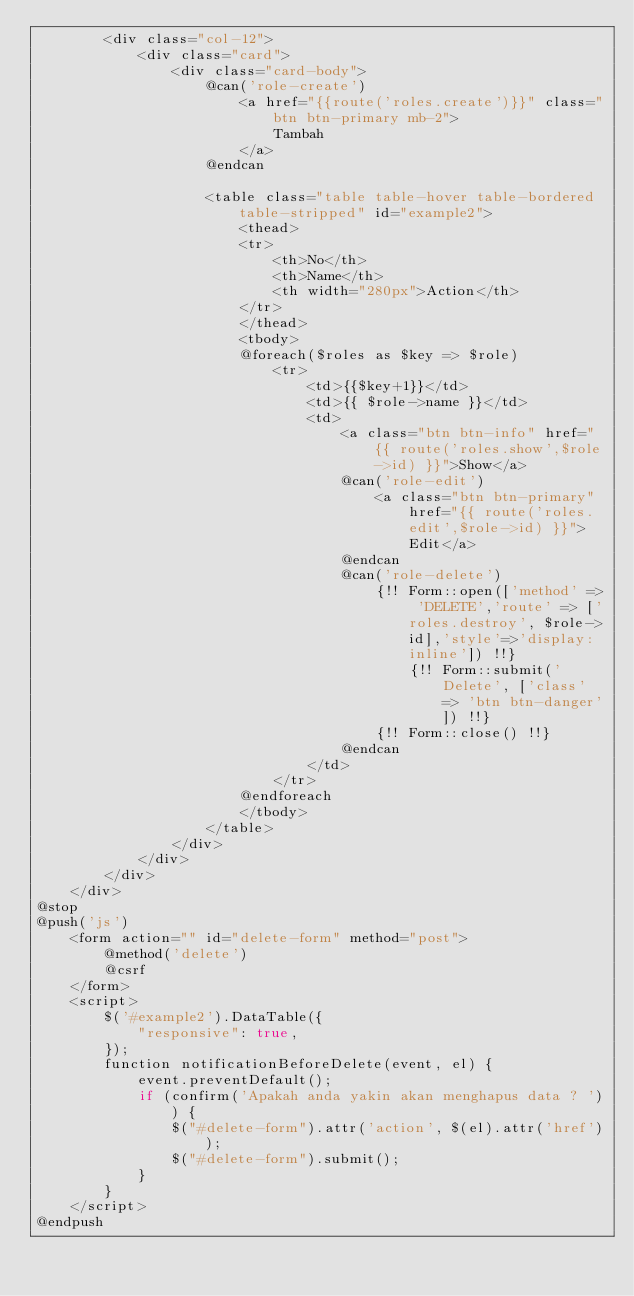Convert code to text. <code><loc_0><loc_0><loc_500><loc_500><_PHP_>        <div class="col-12">
            <div class="card">
                <div class="card-body">
                    @can('role-create')
                        <a href="{{route('roles.create')}}" class="btn btn-primary mb-2">
                            Tambah
                        </a>
                    @endcan

                    <table class="table table-hover table-bordered table-stripped" id="example2">
                        <thead>
                        <tr>
                            <th>No</th>
                            <th>Name</th>
                            <th width="280px">Action</th>
                        </tr>
                        </thead>
                        <tbody>
                        @foreach($roles as $key => $role)
                            <tr>
                                <td>{{$key+1}}</td>
                                <td>{{ $role->name }}</td>
                                <td>
                                    <a class="btn btn-info" href="{{ route('roles.show',$role->id) }}">Show</a>
                                    @can('role-edit')
                                        <a class="btn btn-primary" href="{{ route('roles.edit',$role->id) }}">Edit</a>
                                    @endcan
                                    @can('role-delete')
                                        {!! Form::open(['method' => 'DELETE','route' => ['roles.destroy', $role->id],'style'=>'display:inline']) !!}
                                            {!! Form::submit('Delete', ['class' => 'btn btn-danger']) !!}
                                        {!! Form::close() !!}
                                    @endcan
                                </td>
                            </tr>
                        @endforeach
                        </tbody>
                    </table>
                </div>
            </div>
        </div>
    </div>
@stop
@push('js')
    <form action="" id="delete-form" method="post">
        @method('delete')
        @csrf
    </form>
    <script>
        $('#example2').DataTable({
            "responsive": true,
        });
        function notificationBeforeDelete(event, el) {
            event.preventDefault();
            if (confirm('Apakah anda yakin akan menghapus data ? ')) {
                $("#delete-form").attr('action', $(el).attr('href'));
                $("#delete-form").submit();
            }
        }
    </script>
@endpush
</code> 